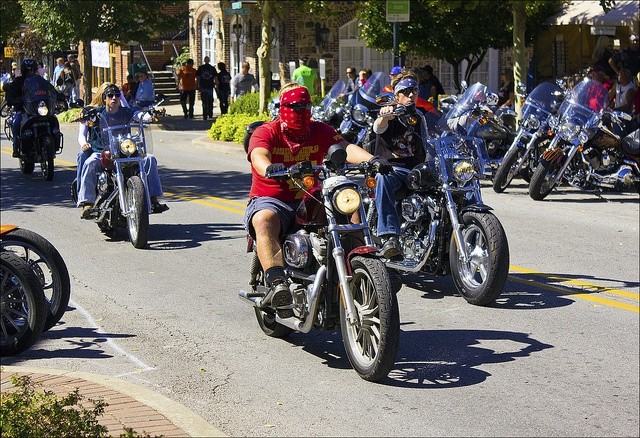Describe the objects in this image and their specific colors. I can see motorcycle in black, gray, lightgray, and darkgray tones, people in black, maroon, gray, and lightgray tones, motorcycle in black, gray, navy, and darkgray tones, motorcycle in black, gray, navy, and darkgray tones, and motorcycle in black, gray, and navy tones in this image. 